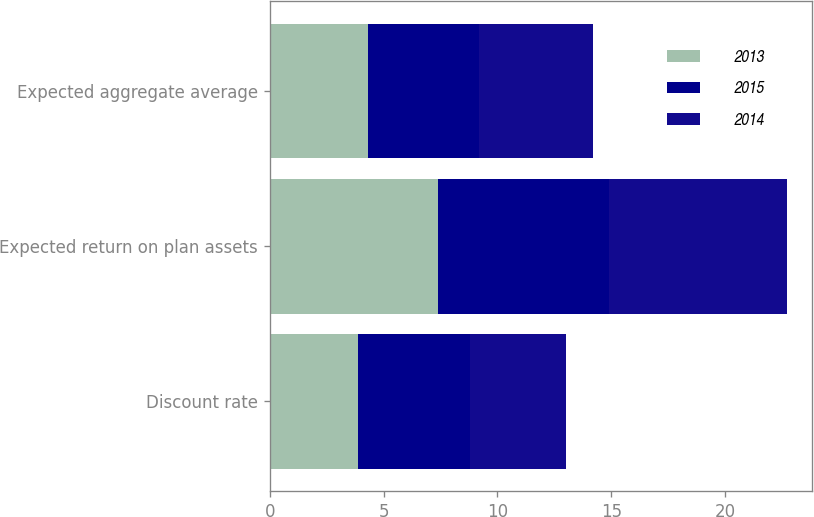Convert chart. <chart><loc_0><loc_0><loc_500><loc_500><stacked_bar_chart><ecel><fcel>Discount rate<fcel>Expected return on plan assets<fcel>Expected aggregate average<nl><fcel>2013<fcel>3.9<fcel>7.4<fcel>4.3<nl><fcel>2015<fcel>4.9<fcel>7.5<fcel>4.9<nl><fcel>2014<fcel>4.2<fcel>7.8<fcel>5<nl></chart> 